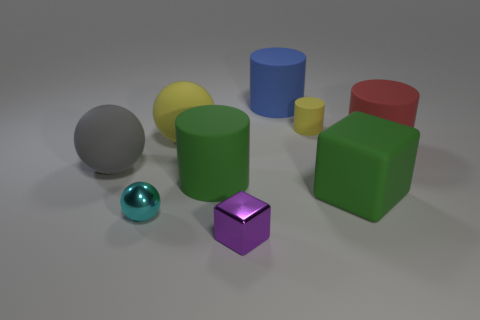There is a small thing that is to the right of the cylinder that is behind the small yellow cylinder behind the large gray rubber ball; what is its color?
Offer a terse response. Yellow. What number of other things are there of the same size as the yellow rubber sphere?
Give a very brief answer. 5. Is there any other thing that is the same shape as the red thing?
Offer a very short reply. Yes. There is another small rubber object that is the same shape as the red matte object; what is its color?
Your answer should be very brief. Yellow. There is a large block that is the same material as the big blue object; what color is it?
Make the answer very short. Green. Are there the same number of objects left of the small cyan metal ball and big blue objects?
Provide a succinct answer. Yes. There is a object that is to the left of the metallic ball; is it the same size as the purple thing?
Provide a succinct answer. No. There is a matte cube that is the same size as the yellow matte sphere; what color is it?
Your answer should be compact. Green. Is there a small sphere to the right of the yellow matte object behind the yellow matte thing that is to the left of the small yellow thing?
Give a very brief answer. No. There is a tiny thing behind the tiny sphere; what is it made of?
Give a very brief answer. Rubber. 